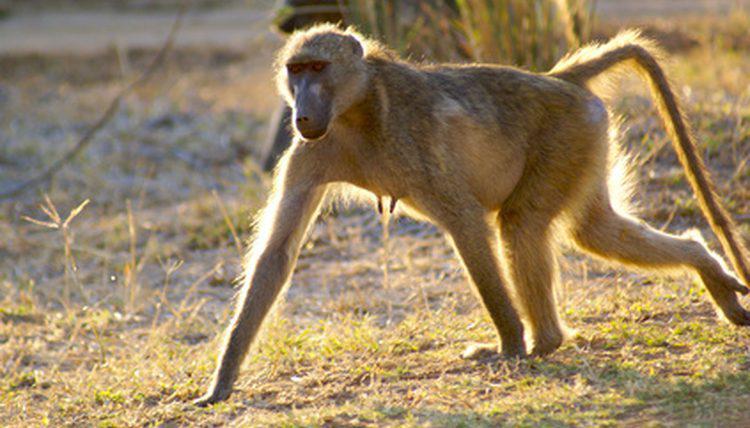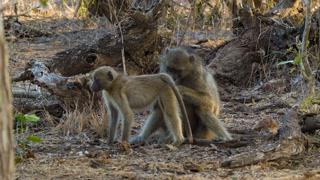The first image is the image on the left, the second image is the image on the right. Assess this claim about the two images: "An image includes a leftward-moving adult baboon walking on all fours, and each image includes one baboon on all fours.". Correct or not? Answer yes or no. Yes. The first image is the image on the left, the second image is the image on the right. Evaluate the accuracy of this statement regarding the images: "There are three monkeys in the pair of images.". Is it true? Answer yes or no. Yes. 